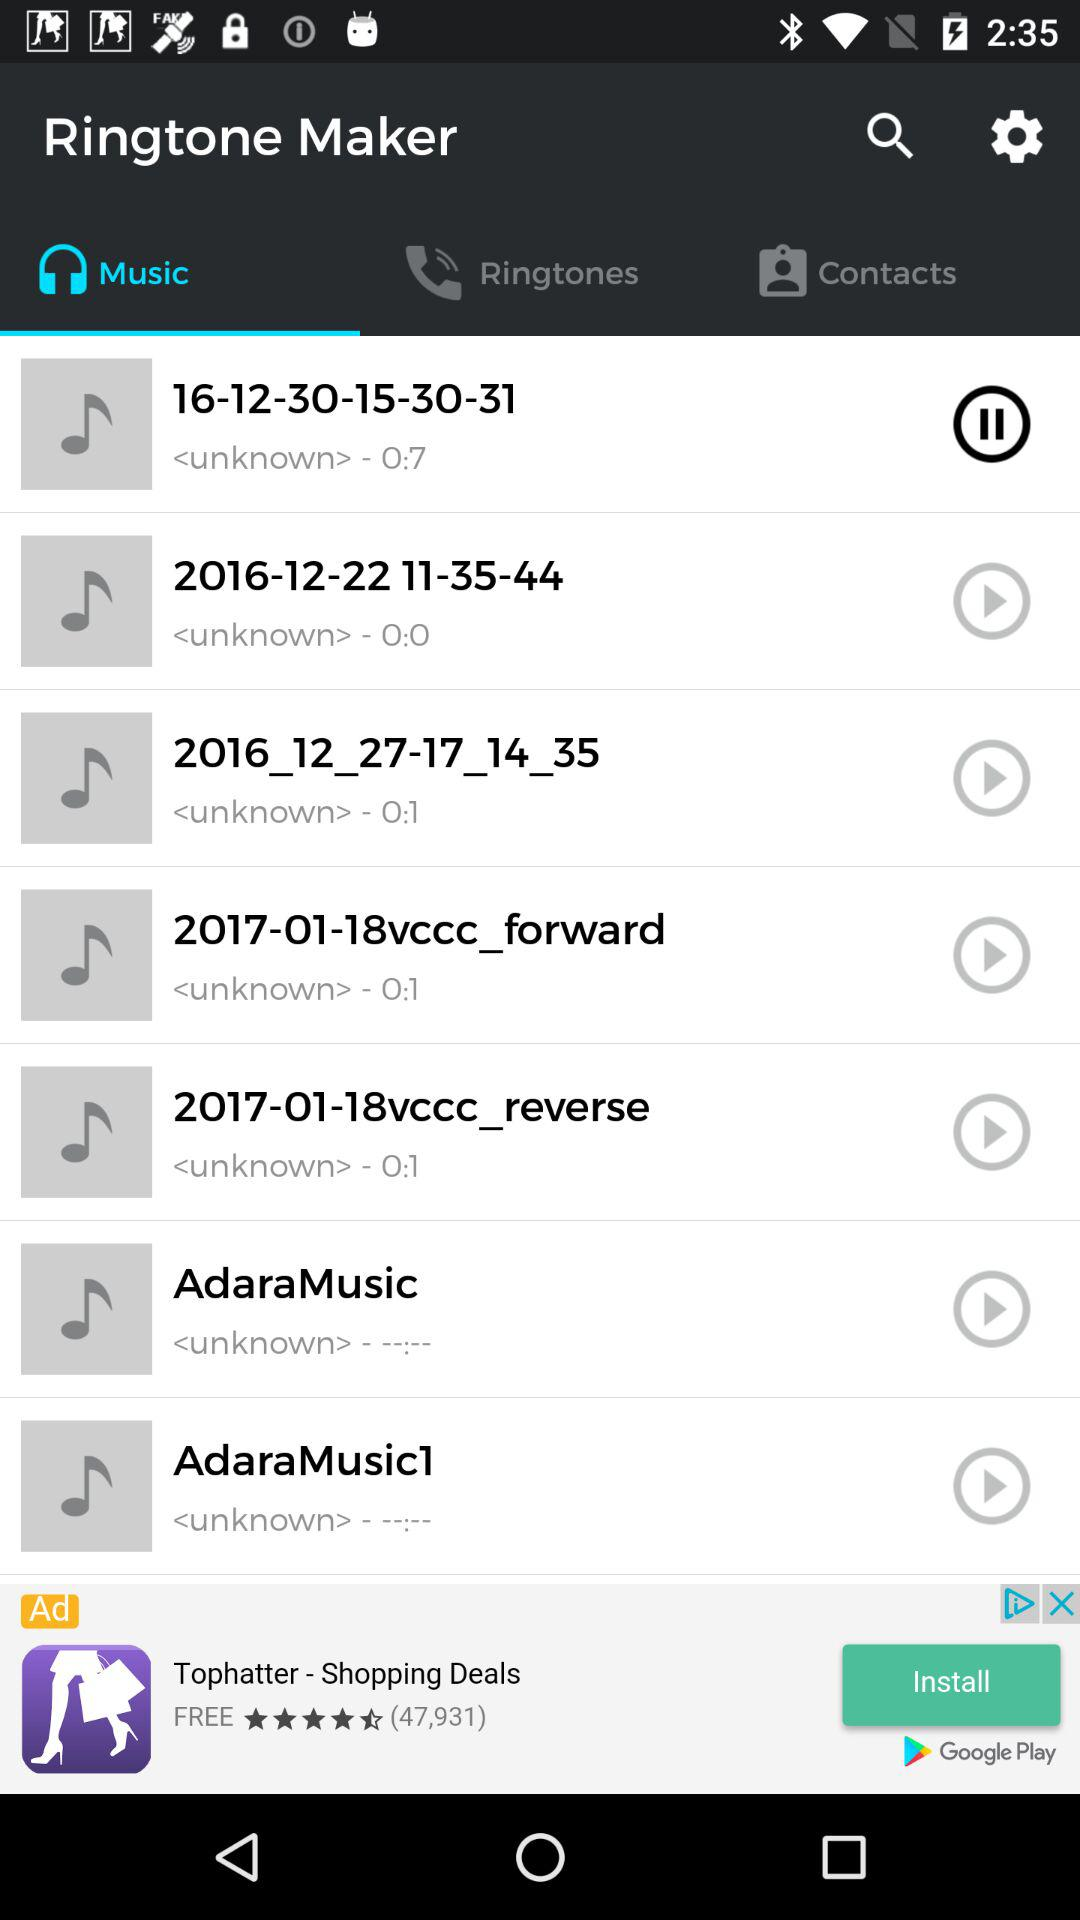Which tab is currently selected? The currently selected tab is "Music". 